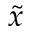Convert formula to latex. <formula><loc_0><loc_0><loc_500><loc_500>\tilde { x }</formula> 